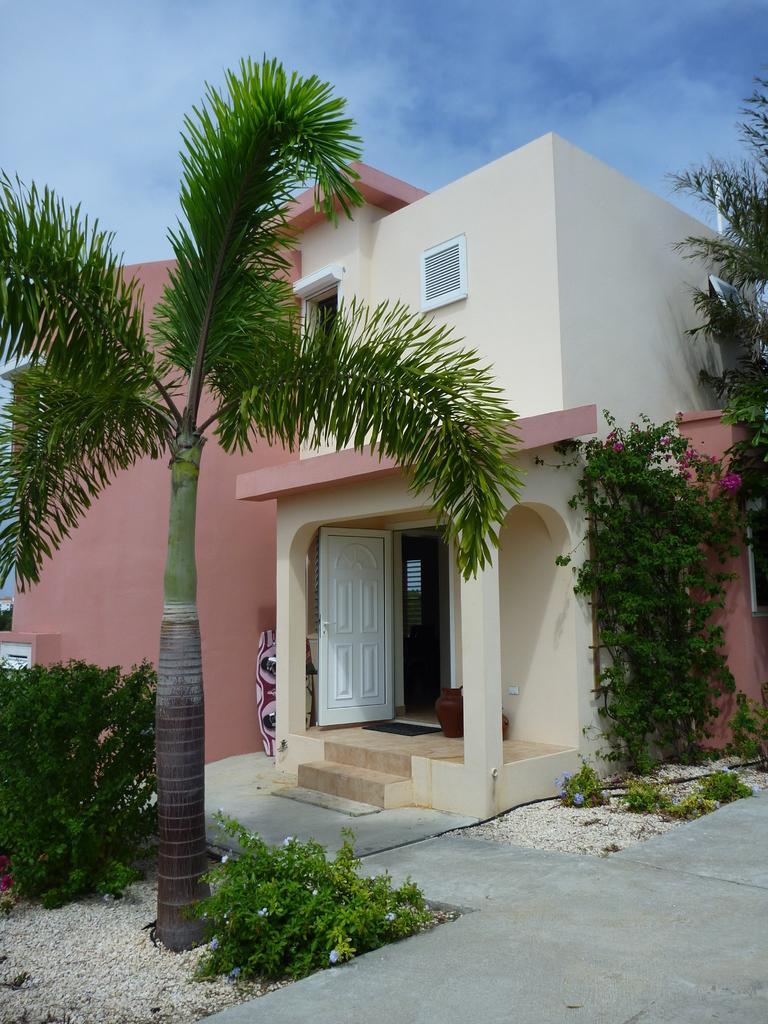Please provide a concise description of this image. Here I can see a building along with the pillars, windows and doors. In front of this building there are plants and trees. At the top of the image I can see the sky. 